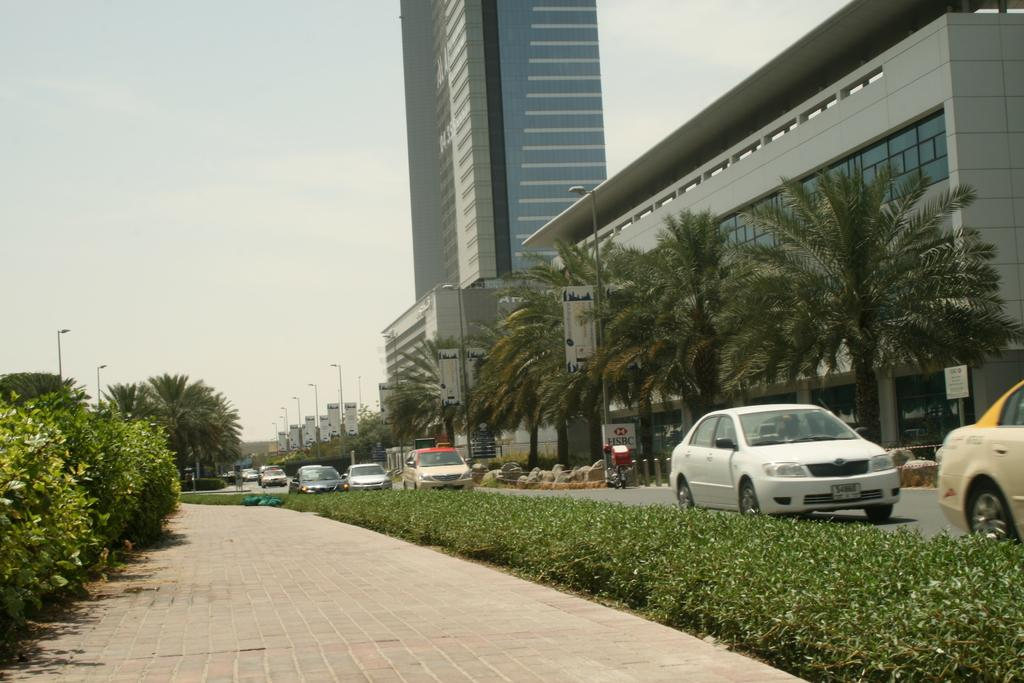What type of structures can be seen in the image? There are buildings in the image. What type of vegetation is present in the image? There are trees and bushes in the image. What are the poles used for in the image? The poles are likely used for supporting wires or signs in the image. What type of objects can be seen on the road in the image? There are vehicles on the road in the image. What is visible at the top of the image? The sky is visible at the top of the image. Can you hear the band playing in the image? There is no band present in the image, so it is not possible to hear them playing. 